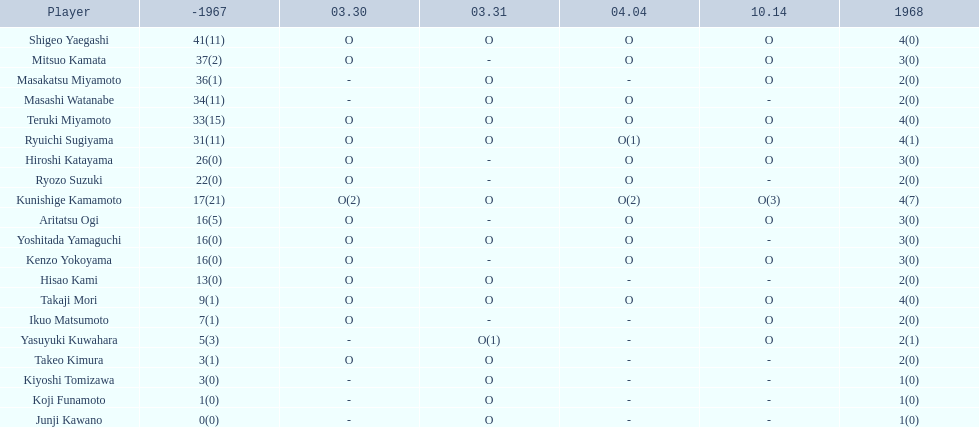Who are all of the players? Shigeo Yaegashi, Mitsuo Kamata, Masakatsu Miyamoto, Masashi Watanabe, Teruki Miyamoto, Ryuichi Sugiyama, Hiroshi Katayama, Ryozo Suzuki, Kunishige Kamamoto, Aritatsu Ogi, Yoshitada Yamaguchi, Kenzo Yokoyama, Hisao Kami, Takaji Mori, Ikuo Matsumoto, Yasuyuki Kuwahara, Takeo Kimura, Kiyoshi Tomizawa, Koji Funamoto, Junji Kawano. How many points did they receive? 45(11), 40(2), 38(1), 36(11), 37(15), 35(12), 29(0), 24(0), 21(28), 19(5), 19(0), 19(0), 15(0), 13(1), 9(1), 7(4), 5(1), 4(0), 2(0), 1(0). What about just takaji mori and junji kawano? 13(1), 1(0). Of the two, who had more points? Takaji Mori. 